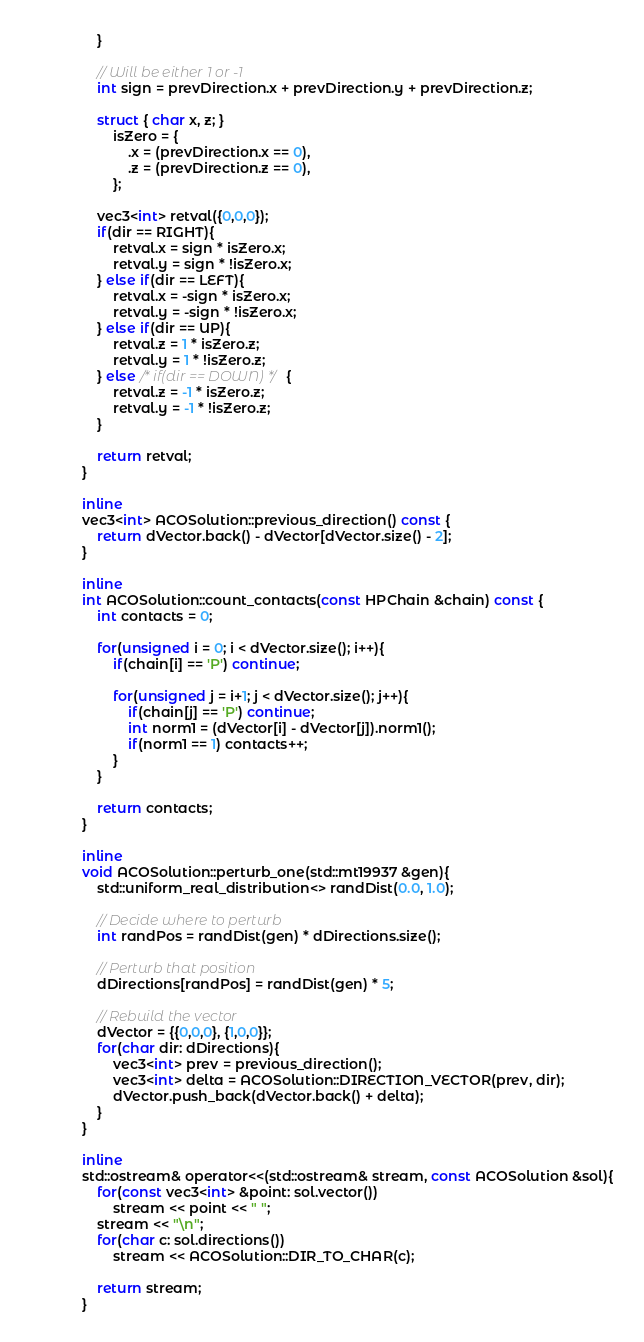<code> <loc_0><loc_0><loc_500><loc_500><_C_>	}

	// Will be either 1 or -1
	int sign = prevDirection.x + prevDirection.y + prevDirection.z;

	struct { char x, z; }
		isZero = {
			.x = (prevDirection.x == 0),
			.z = (prevDirection.z == 0),
		};
	
	vec3<int> retval({0,0,0});
	if(dir == RIGHT){
		retval.x = sign * isZero.x;
		retval.y = sign * !isZero.x;
	} else if(dir == LEFT){
		retval.x = -sign * isZero.x;
		retval.y = -sign * !isZero.x;
	} else if(dir == UP){
		retval.z = 1 * isZero.z;
		retval.y = 1 * !isZero.z;
	} else /* if(dir == DOWN) */ {
		retval.z = -1 * isZero.z;
		retval.y = -1 * !isZero.z;
	}

	return retval;
}

inline
vec3<int> ACOSolution::previous_direction() const {
	return dVector.back() - dVector[dVector.size() - 2];
}

inline
int ACOSolution::count_contacts(const HPChain &chain) const {
	int contacts = 0;

	for(unsigned i = 0; i < dVector.size(); i++){
		if(chain[i] == 'P') continue;

		for(unsigned j = i+1; j < dVector.size(); j++){
			if(chain[j] == 'P') continue;
			int norm1 = (dVector[i] - dVector[j]).norm1();
			if(norm1 == 1) contacts++;
		}
	}

	return contacts;
}

inline
void ACOSolution::perturb_one(std::mt19937 &gen){
	std::uniform_real_distribution<> randDist(0.0, 1.0);

	// Decide where to perturb
	int randPos = randDist(gen) * dDirections.size();

	// Perturb that position
	dDirections[randPos] = randDist(gen) * 5;

	// Rebuild the vector
	dVector = {{0,0,0}, {1,0,0}};
	for(char dir: dDirections){
		vec3<int> prev = previous_direction();
		vec3<int> delta = ACOSolution::DIRECTION_VECTOR(prev, dir);
		dVector.push_back(dVector.back() + delta);
	}
}

inline
std::ostream& operator<<(std::ostream& stream, const ACOSolution &sol){
	for(const vec3<int> &point: sol.vector())
		stream << point << " ";
	stream << "\n";
	for(char c: sol.directions())
		stream << ACOSolution::DIR_TO_CHAR(c);

	return stream;
}
</code> 